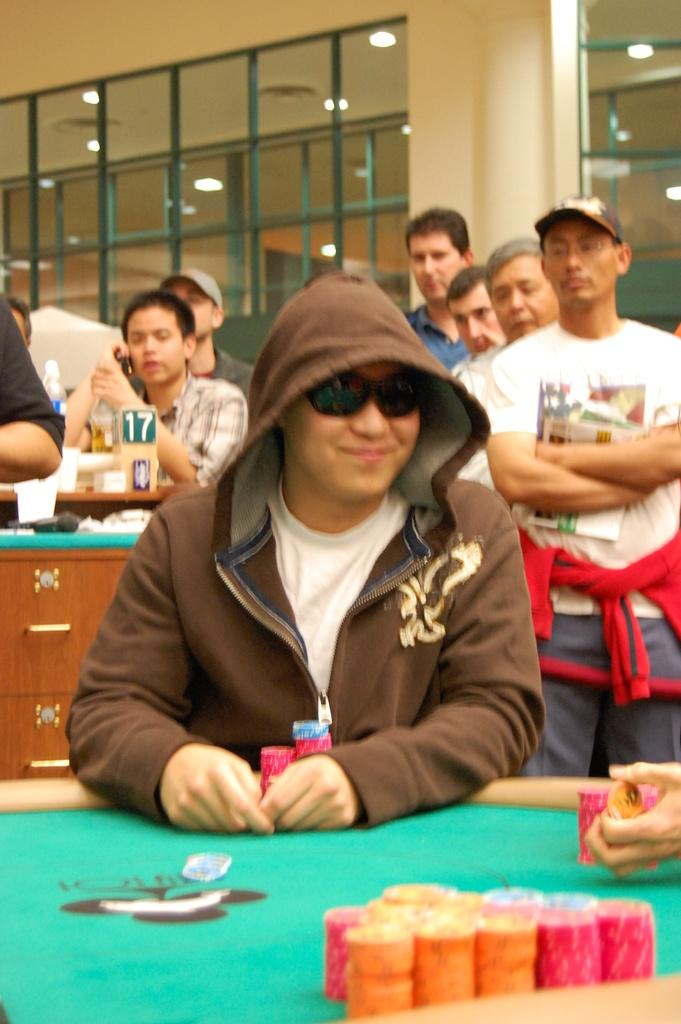What is the main subject of the image? The main subject of the image is a group of people. Can you describe any objects or items present in the image? Yes, there are coins on a table in the image. What type of insect can be seen helping the fireman in the image? There is no fireman or insect present in the image. 